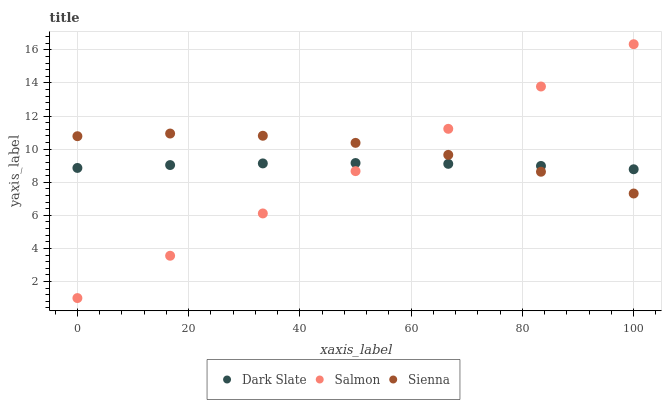Does Salmon have the minimum area under the curve?
Answer yes or no. Yes. Does Sienna have the maximum area under the curve?
Answer yes or no. Yes. Does Dark Slate have the minimum area under the curve?
Answer yes or no. No. Does Dark Slate have the maximum area under the curve?
Answer yes or no. No. Is Salmon the smoothest?
Answer yes or no. Yes. Is Sienna the roughest?
Answer yes or no. Yes. Is Dark Slate the smoothest?
Answer yes or no. No. Is Dark Slate the roughest?
Answer yes or no. No. Does Salmon have the lowest value?
Answer yes or no. Yes. Does Dark Slate have the lowest value?
Answer yes or no. No. Does Salmon have the highest value?
Answer yes or no. Yes. Does Dark Slate have the highest value?
Answer yes or no. No. Does Salmon intersect Dark Slate?
Answer yes or no. Yes. Is Salmon less than Dark Slate?
Answer yes or no. No. Is Salmon greater than Dark Slate?
Answer yes or no. No. 